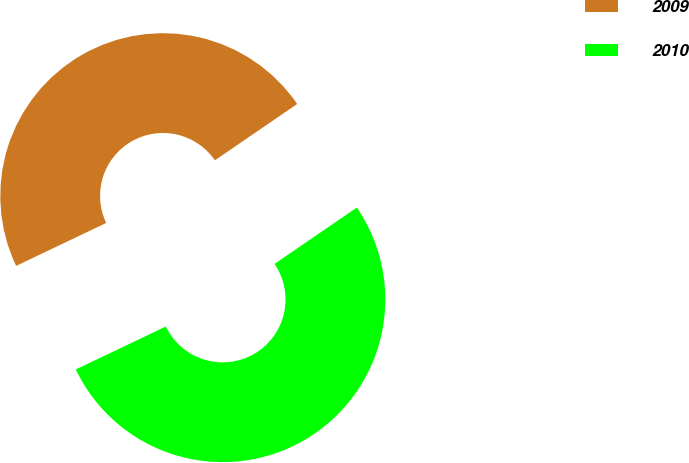<chart> <loc_0><loc_0><loc_500><loc_500><pie_chart><fcel>2009<fcel>2010<nl><fcel>47.52%<fcel>52.48%<nl></chart> 